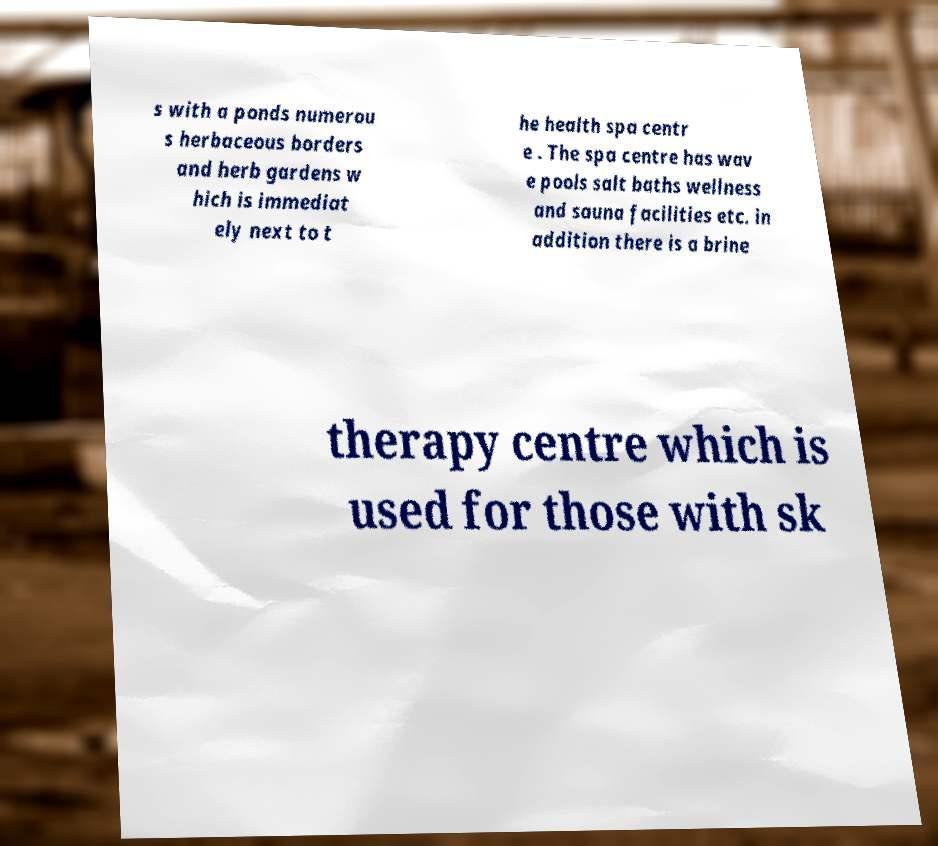There's text embedded in this image that I need extracted. Can you transcribe it verbatim? s with a ponds numerou s herbaceous borders and herb gardens w hich is immediat ely next to t he health spa centr e . The spa centre has wav e pools salt baths wellness and sauna facilities etc. in addition there is a brine therapy centre which is used for those with sk 